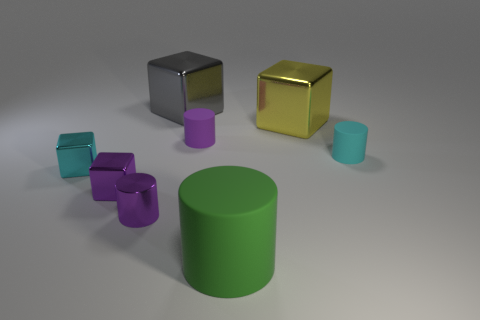There is a purple thing that is on the right side of the gray metallic thing; is its shape the same as the gray metallic thing?
Make the answer very short. No. There is a metallic thing that is to the right of the small purple rubber cylinder; what is its shape?
Your response must be concise. Cube. There is a small rubber object that is the same color as the shiny cylinder; what shape is it?
Ensure brevity in your answer.  Cylinder. How many other objects are the same size as the green object?
Keep it short and to the point. 2. What is the color of the metallic cylinder?
Provide a succinct answer. Purple. Do the small metal cylinder and the small rubber object that is to the left of the cyan cylinder have the same color?
Your answer should be very brief. Yes. There is a purple cylinder that is the same material as the small cyan block; what is its size?
Give a very brief answer. Small. Are there any big blocks that have the same color as the metal cylinder?
Ensure brevity in your answer.  No. How many objects are either tiny matte cylinders behind the tiny cyan rubber thing or tiny purple shiny things?
Your answer should be very brief. 3. Is the large gray block made of the same material as the tiny cube that is behind the tiny purple cube?
Ensure brevity in your answer.  Yes. 